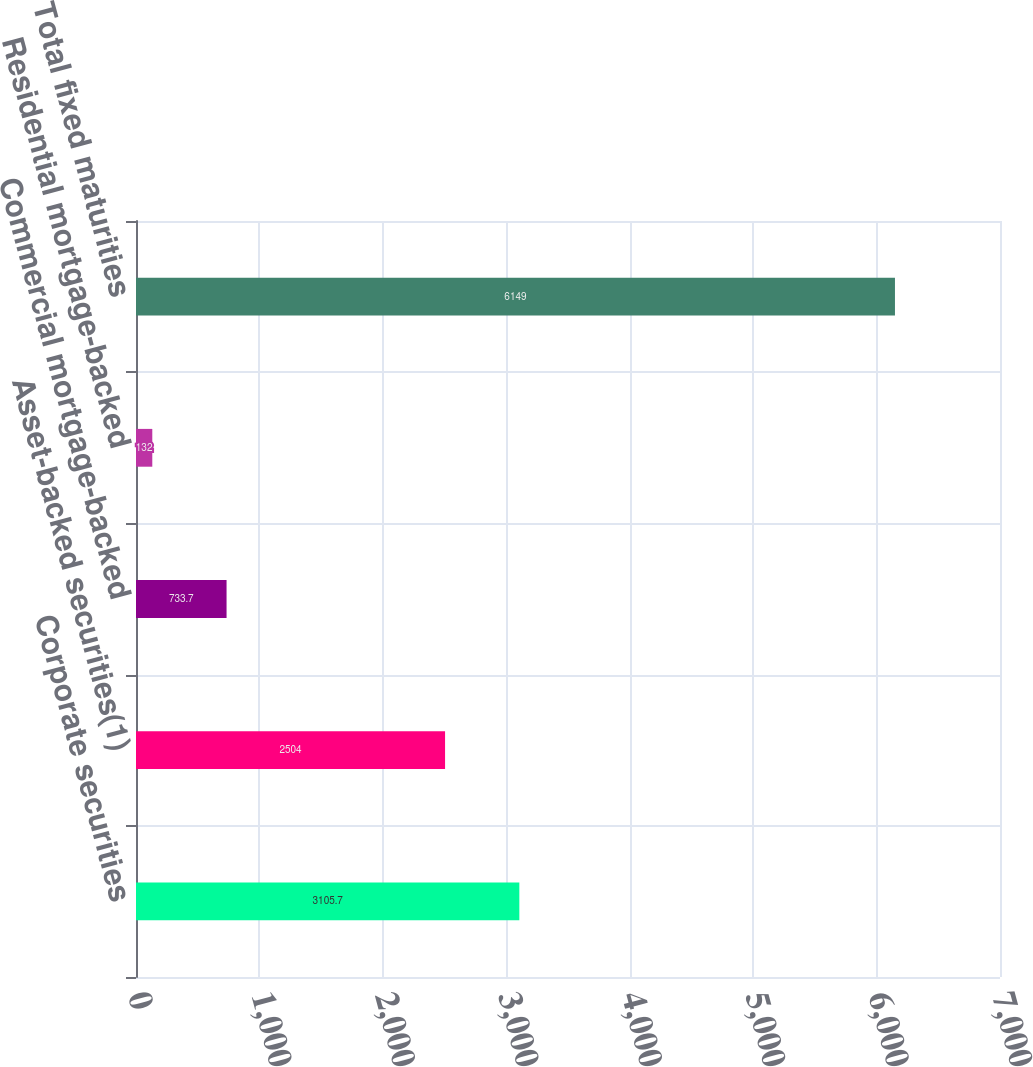Convert chart. <chart><loc_0><loc_0><loc_500><loc_500><bar_chart><fcel>Corporate securities<fcel>Asset-backed securities(1)<fcel>Commercial mortgage-backed<fcel>Residential mortgage-backed<fcel>Total fixed maturities<nl><fcel>3105.7<fcel>2504<fcel>733.7<fcel>132<fcel>6149<nl></chart> 